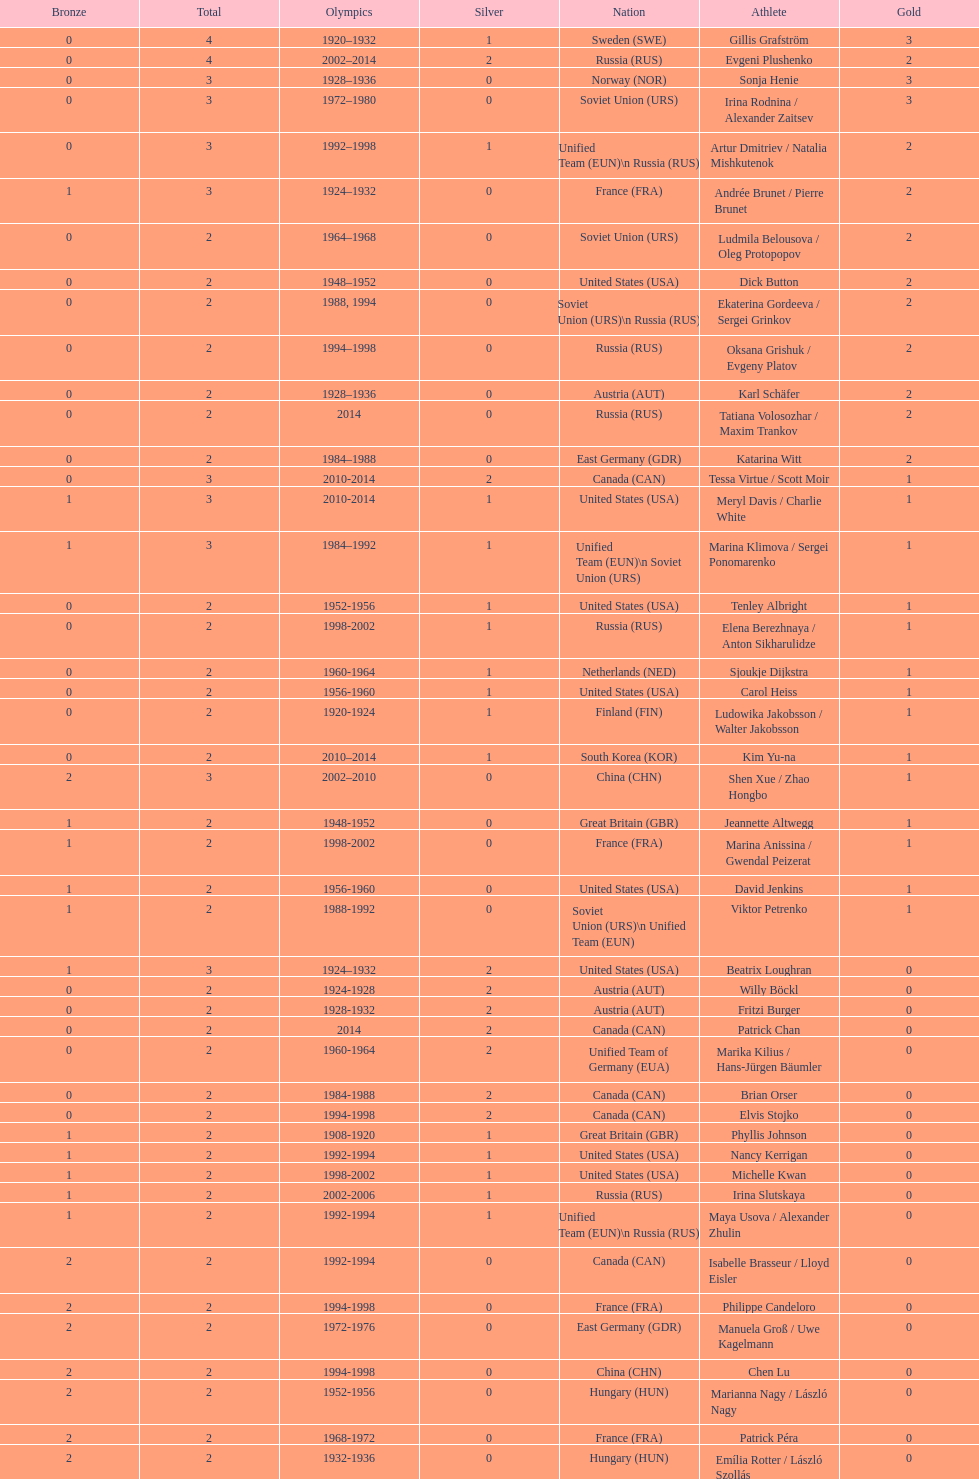How many silver medals did evgeni plushenko get? 2. 